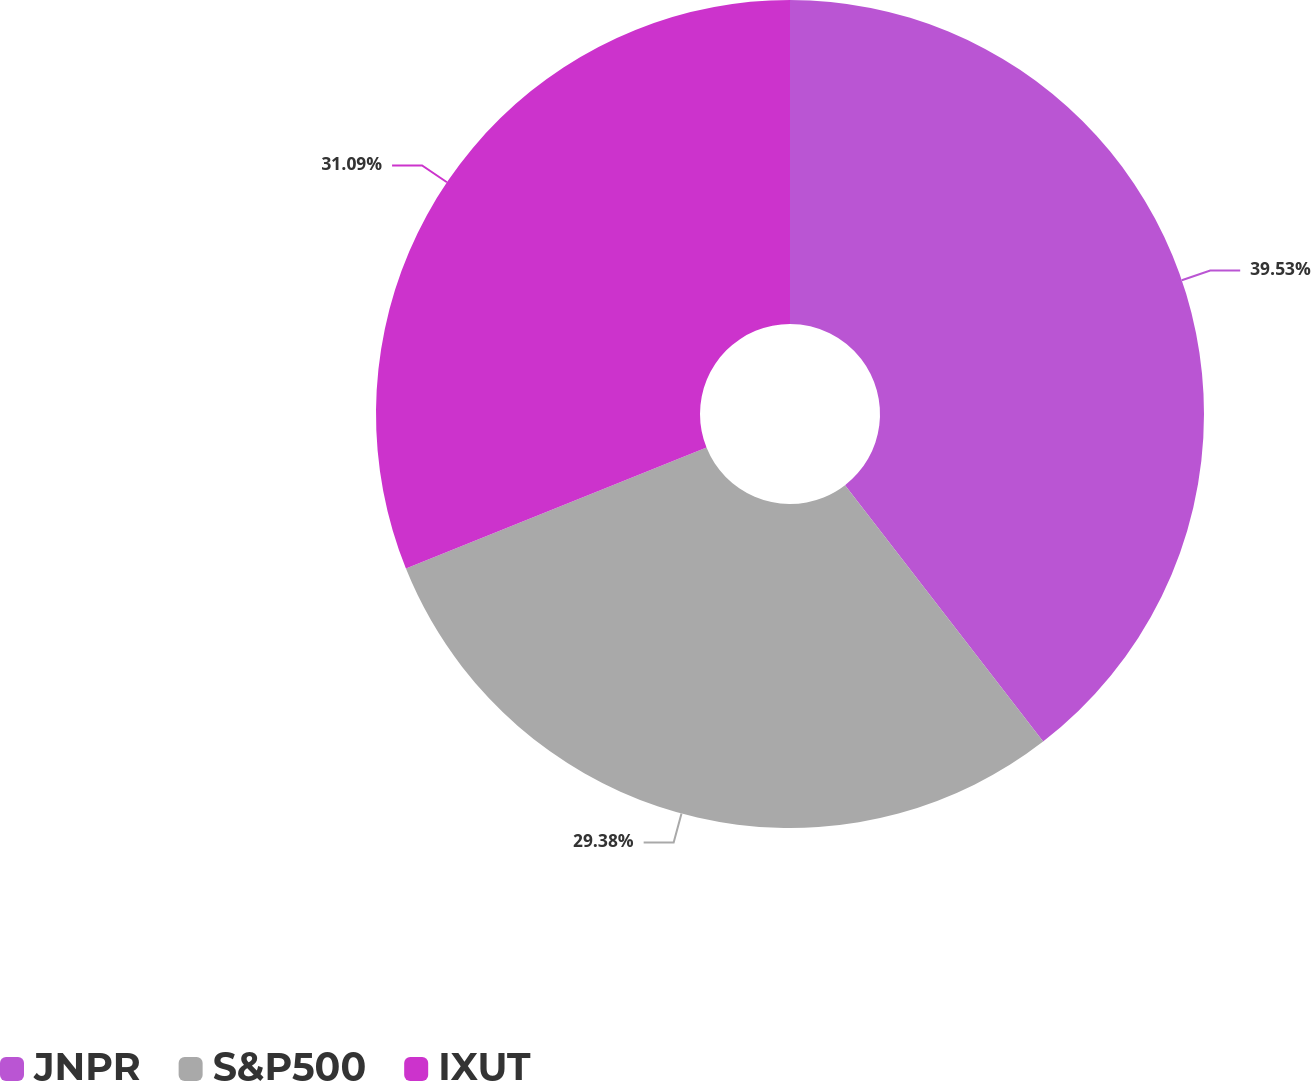<chart> <loc_0><loc_0><loc_500><loc_500><pie_chart><fcel>JNPR<fcel>S&P500<fcel>IXUT<nl><fcel>39.53%<fcel>29.38%<fcel>31.09%<nl></chart> 